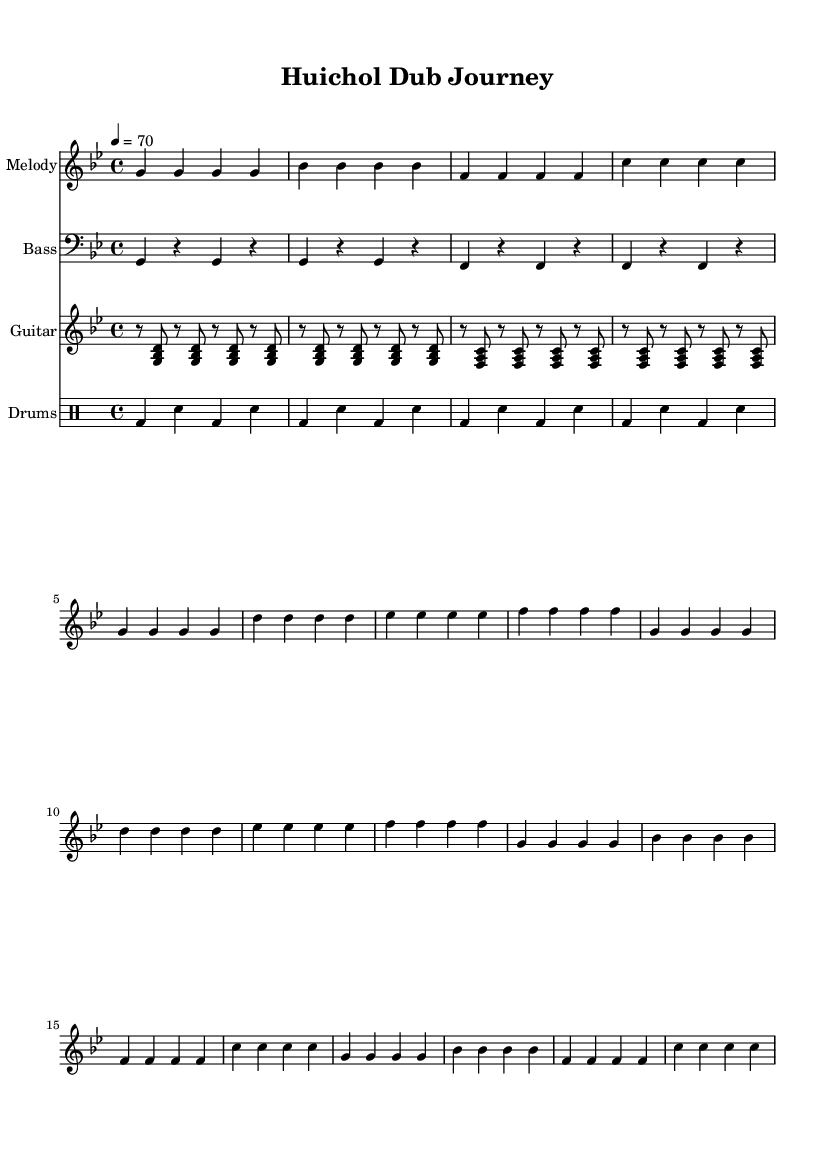What is the key signature of this music? The key signature is G minor, which has two flats indicated by the placement of the flat symbols on the staff.
Answer: G minor What is the time signature in this music? The time signature is indicated at the beginning of the music as 4/4, meaning there are four beats in each measure.
Answer: 4/4 What is the tempo marking in this sheet music? The tempo marking indicates a speed of 70 beats per minute, usually described as "quarter note = 70."
Answer: 70 How many measures are in the melody section? The melody section consists of 16 measures, as counted by the number of vertical lines separating the measures.
Answer: 16 What note is played at the start of the melody? The first note in the melody is G, which is located on the second line of the treble clef staff.
Answer: G What type of rhythm pattern is predominantly used in the drum section? The drum section predominantly features a simple alternating pattern of bass and snare drums, characterized by consistent quarter-note beats.
Answer: Alternating bass/snare Which indigenous elements can be identified in the context of this song? The song's title references "Huichol," which is an indigenous group known for their vibrant storytelling and music, influencing the thematic elements present in the composition.
Answer: Huichol 